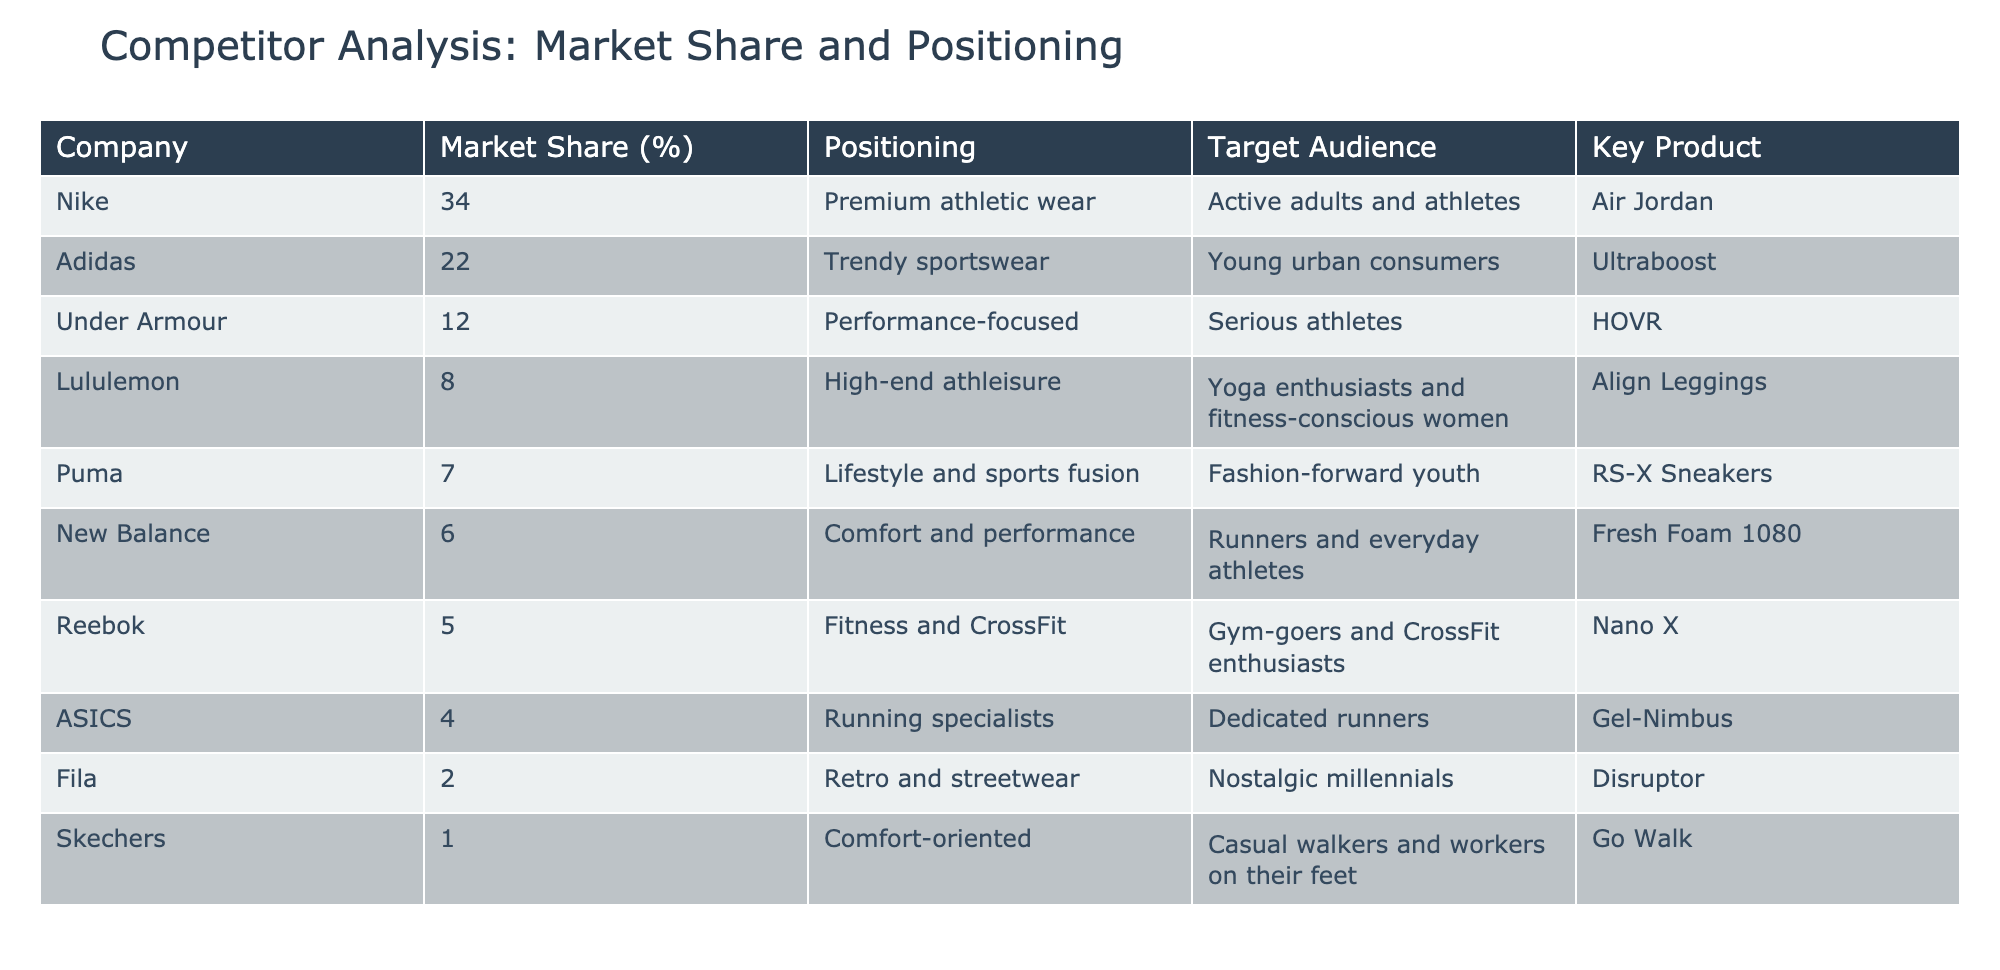What is the market share of Nike? The table shows that the market share of Nike is listed under the "Market Share (%)" column, which clearly states that it is 34 percent.
Answer: 34% Which company has the lowest market share? By looking through the "Market Share (%)" column, it's evident that Skechers has the lowest value at 1 percent.
Answer: Skechers Is Adidas targeting serious athletes? The table lists Adidas under "Target Audience," which indicates it targets young urban consumers, not serious athletes. Therefore, the answer is no.
Answer: No What is the combined market share of New Balance and Reebok? To find the combined market share, add the values for New Balance (6%) and Reebok (5%). The calculation is 6 + 5 = 11.
Answer: 11% Which brand has the highest positioning according to the table? The table lists Nike as "Premium athletic wear," which is considered high positioning among athletic brands. A comparison with others confirms this is the highest.
Answer: Nike What percentage of market share do the top three companies hold collectively? The top three companies are Nike (34%), Adidas (22%), and Under Armour (12%). Adding these gives 34 + 22 + 12 = 68%.
Answer: 68% Is Lululemon focused on performance? The positioning for Lululemon in the table is stated as "High-end athleisure," which suggests a focus on lifestyle rather than pure performance. Hence, the answer is no.
Answer: No Which target audience does Puma focus on? The table specifies that Puma targets "Fashion-forward youth," which can be found in the "Target Audience" column.
Answer: Fashion-forward youth What is the average market share of the companies listed? There are 10 companies listed. The total market share can be calculated: 34 + 22 + 12 + 8 + 7 + 6 + 5 + 4 + 2 + 1 = 101. Then, to find the average, divide by 10. So, the average is 101 / 10 = 10.1%.
Answer: 10.1% 